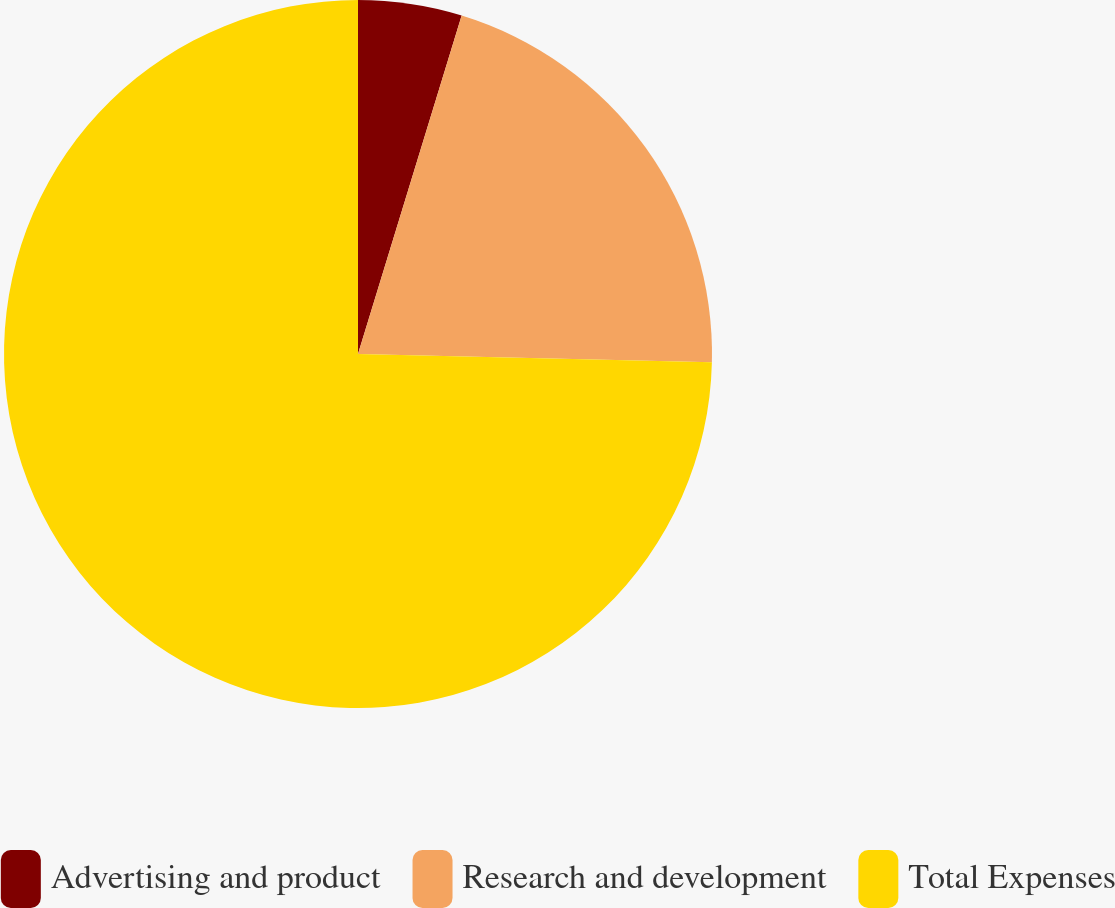Convert chart to OTSL. <chart><loc_0><loc_0><loc_500><loc_500><pie_chart><fcel>Advertising and product<fcel>Research and development<fcel>Total Expenses<nl><fcel>4.73%<fcel>20.64%<fcel>74.63%<nl></chart> 